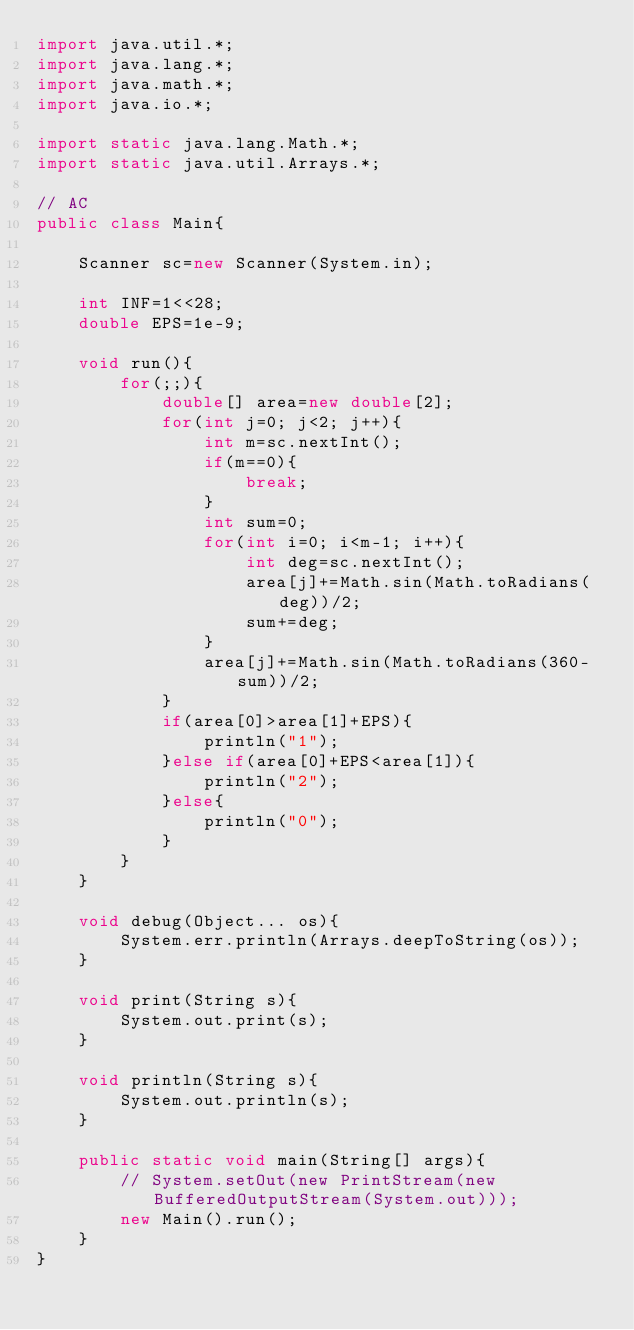<code> <loc_0><loc_0><loc_500><loc_500><_Java_>import java.util.*;
import java.lang.*;
import java.math.*;
import java.io.*;

import static java.lang.Math.*;
import static java.util.Arrays.*;

// AC
public class Main{

	Scanner sc=new Scanner(System.in);

	int INF=1<<28;
	double EPS=1e-9;

	void run(){
		for(;;){
			double[] area=new double[2];
			for(int j=0; j<2; j++){
				int m=sc.nextInt();
				if(m==0){
					break;
				}
				int sum=0;
				for(int i=0; i<m-1; i++){
					int deg=sc.nextInt();
					area[j]+=Math.sin(Math.toRadians(deg))/2;
					sum+=deg;
				}
				area[j]+=Math.sin(Math.toRadians(360-sum))/2;
			}
			if(area[0]>area[1]+EPS){
				println("1");
			}else if(area[0]+EPS<area[1]){
				println("2");
			}else{
				println("0");
			}
		}
	}

	void debug(Object... os){
		System.err.println(Arrays.deepToString(os));
	}

	void print(String s){
		System.out.print(s);
	}

	void println(String s){
		System.out.println(s);
	}

	public static void main(String[] args){
		// System.setOut(new PrintStream(new BufferedOutputStream(System.out)));
		new Main().run();
	}
}</code> 